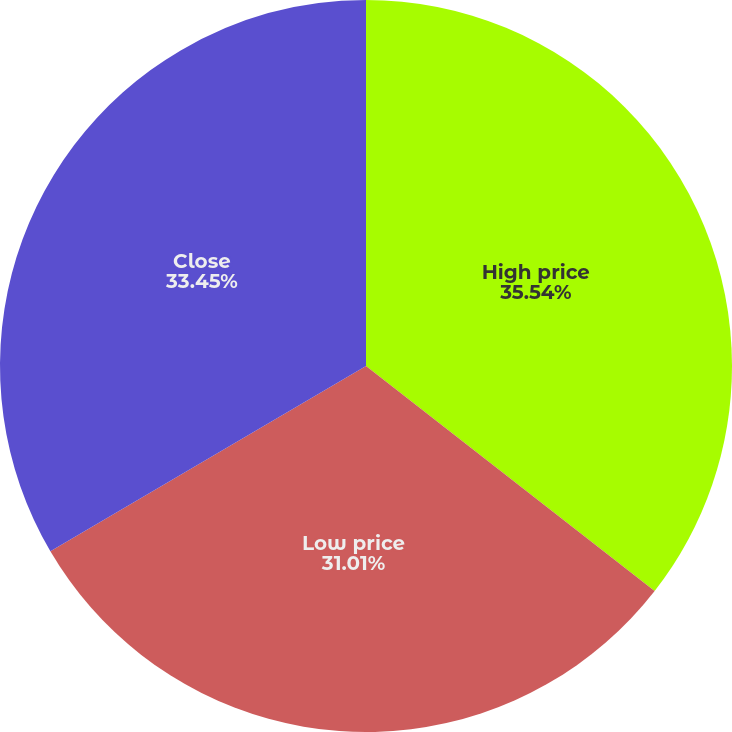Convert chart to OTSL. <chart><loc_0><loc_0><loc_500><loc_500><pie_chart><fcel>High price<fcel>Low price<fcel>Close<nl><fcel>35.54%<fcel>31.01%<fcel>33.45%<nl></chart> 